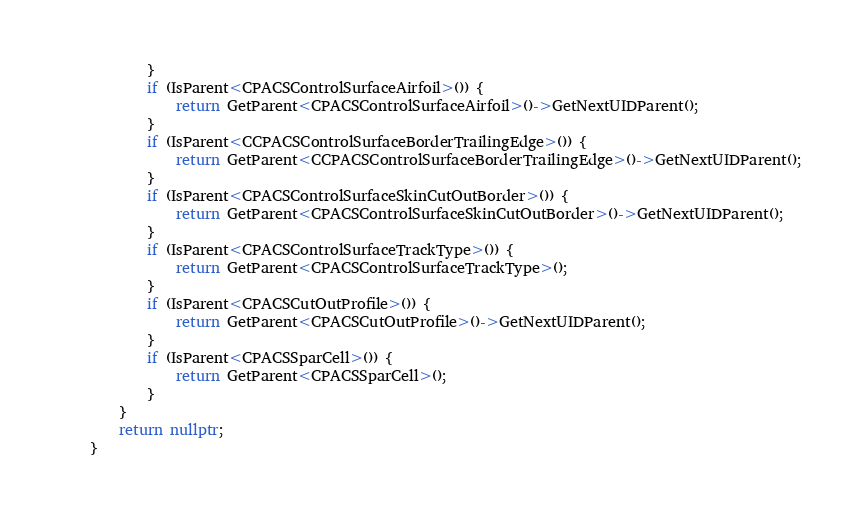Convert code to text. <code><loc_0><loc_0><loc_500><loc_500><_C++_>            }
            if (IsParent<CPACSControlSurfaceAirfoil>()) {
                return GetParent<CPACSControlSurfaceAirfoil>()->GetNextUIDParent();
            }
            if (IsParent<CCPACSControlSurfaceBorderTrailingEdge>()) {
                return GetParent<CCPACSControlSurfaceBorderTrailingEdge>()->GetNextUIDParent();
            }
            if (IsParent<CPACSControlSurfaceSkinCutOutBorder>()) {
                return GetParent<CPACSControlSurfaceSkinCutOutBorder>()->GetNextUIDParent();
            }
            if (IsParent<CPACSControlSurfaceTrackType>()) {
                return GetParent<CPACSControlSurfaceTrackType>();
            }
            if (IsParent<CPACSCutOutProfile>()) {
                return GetParent<CPACSCutOutProfile>()->GetNextUIDParent();
            }
            if (IsParent<CPACSSparCell>()) {
                return GetParent<CPACSSparCell>();
            }
        }
        return nullptr;
    }
</code> 